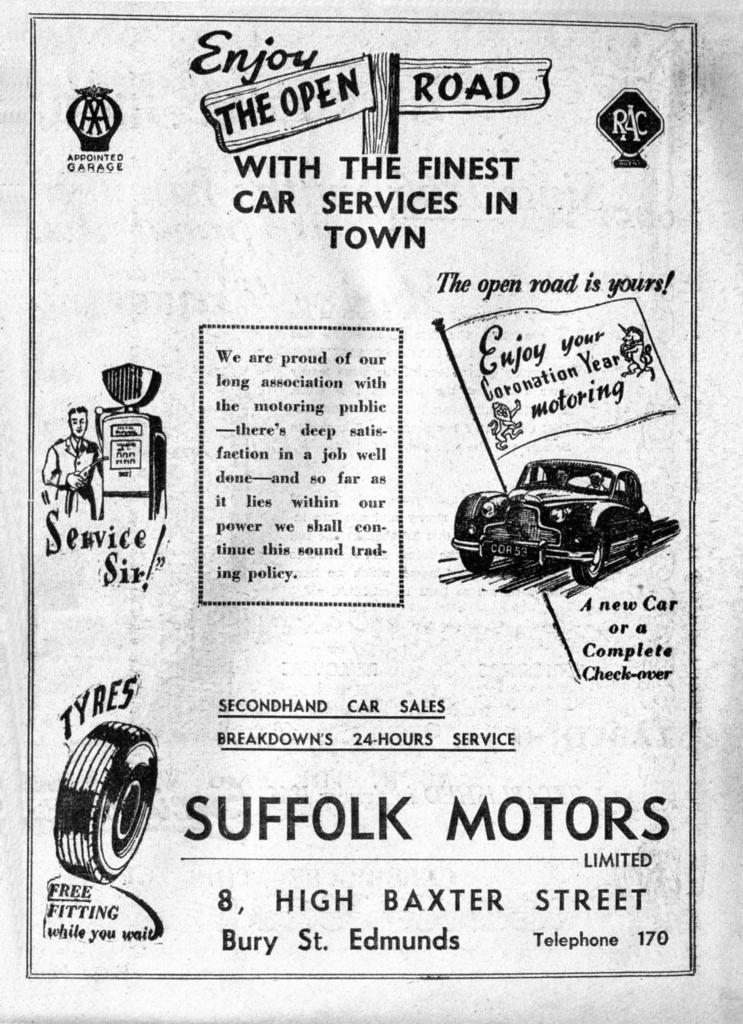What type of visual is the image? The image is a poster. What can be seen on the poster? There are depictions and logos on the poster. Is there any textual information on the poster? Yes, there is some information on the poster. How does the boy interact with the salt on the poster? There is no boy or salt present on the poster; it only contains depictions, logos, and information. 